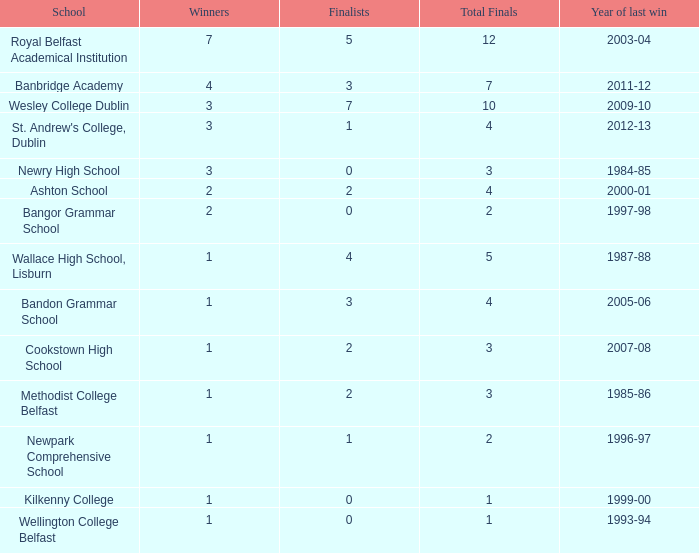How often has banbridge academy won? 1.0. 